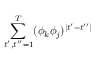<formula> <loc_0><loc_0><loc_500><loc_500>\sum _ { t ^ { \prime } , t ^ { \prime \prime } = 1 } ^ { T } ( \phi _ { k } \phi _ { j } ) ^ { | t ^ { \prime } - t ^ { \prime \prime } | }</formula> 